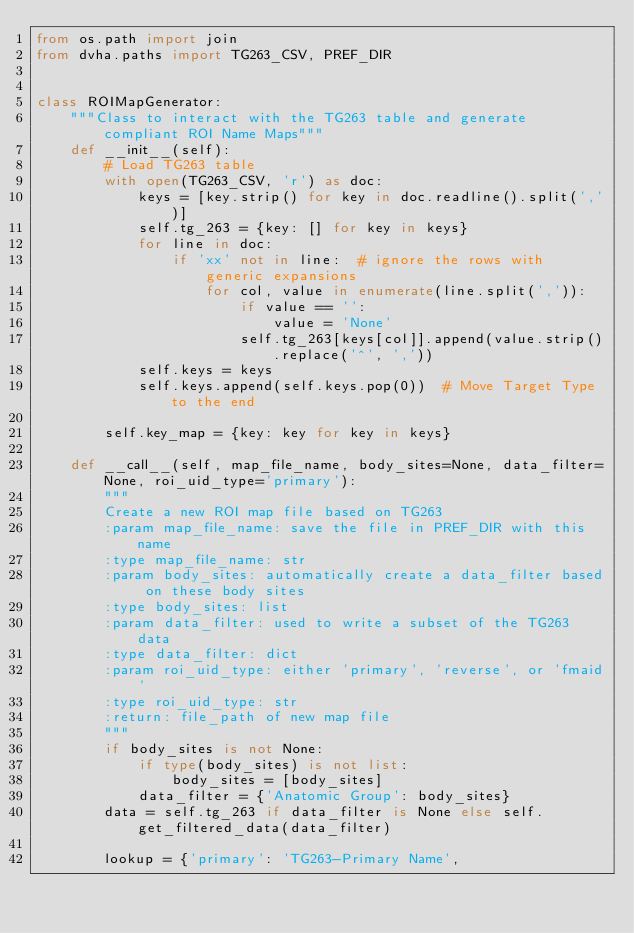Convert code to text. <code><loc_0><loc_0><loc_500><loc_500><_Python_>from os.path import join
from dvha.paths import TG263_CSV, PREF_DIR


class ROIMapGenerator:
    """Class to interact with the TG263 table and generate compliant ROI Name Maps"""
    def __init__(self):
        # Load TG263 table
        with open(TG263_CSV, 'r') as doc:
            keys = [key.strip() for key in doc.readline().split(',')]
            self.tg_263 = {key: [] for key in keys}
            for line in doc:
                if 'xx' not in line:  # ignore the rows with generic expansions
                    for col, value in enumerate(line.split(',')):
                        if value == '':
                            value = 'None'
                        self.tg_263[keys[col]].append(value.strip().replace('^', ','))
            self.keys = keys
            self.keys.append(self.keys.pop(0))  # Move Target Type to the end

        self.key_map = {key: key for key in keys}

    def __call__(self, map_file_name, body_sites=None, data_filter=None, roi_uid_type='primary'):
        """
        Create a new ROI map file based on TG263
        :param map_file_name: save the file in PREF_DIR with this name
        :type map_file_name: str
        :param body_sites: automatically create a data_filter based on these body sites
        :type body_sites: list
        :param data_filter: used to write a subset of the TG263 data
        :type data_filter: dict
        :param roi_uid_type: either 'primary', 'reverse', or 'fmaid'
        :type roi_uid_type: str
        :return: file_path of new map file
        """
        if body_sites is not None:
            if type(body_sites) is not list:
                body_sites = [body_sites]
            data_filter = {'Anatomic Group': body_sites}
        data = self.tg_263 if data_filter is None else self.get_filtered_data(data_filter)

        lookup = {'primary': 'TG263-Primary Name',</code> 